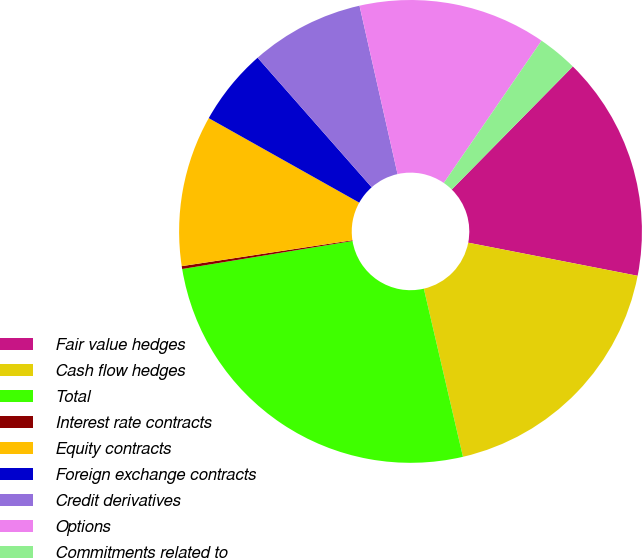Convert chart. <chart><loc_0><loc_0><loc_500><loc_500><pie_chart><fcel>Fair value hedges<fcel>Cash flow hedges<fcel>Total<fcel>Interest rate contracts<fcel>Equity contracts<fcel>Foreign exchange contracts<fcel>Credit derivatives<fcel>Options<fcel>Commitments related to<nl><fcel>15.7%<fcel>18.29%<fcel>26.04%<fcel>0.2%<fcel>10.54%<fcel>5.37%<fcel>7.95%<fcel>13.12%<fcel>2.79%<nl></chart> 